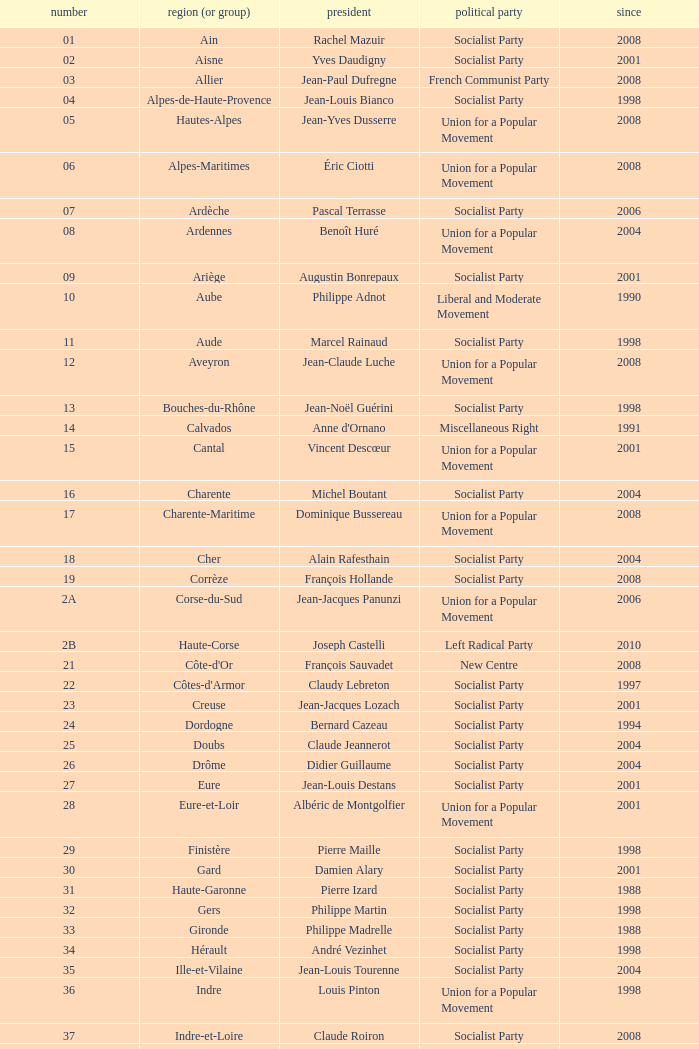Which department has Guy-Dominique Kennel as president since 2008? Bas-Rhin. Could you parse the entire table? {'header': ['number', 'region (or group)', 'president', 'political party', 'since'], 'rows': [['01', 'Ain', 'Rachel Mazuir', 'Socialist Party', '2008'], ['02', 'Aisne', 'Yves Daudigny', 'Socialist Party', '2001'], ['03', 'Allier', 'Jean-Paul Dufregne', 'French Communist Party', '2008'], ['04', 'Alpes-de-Haute-Provence', 'Jean-Louis Bianco', 'Socialist Party', '1998'], ['05', 'Hautes-Alpes', 'Jean-Yves Dusserre', 'Union for a Popular Movement', '2008'], ['06', 'Alpes-Maritimes', 'Éric Ciotti', 'Union for a Popular Movement', '2008'], ['07', 'Ardèche', 'Pascal Terrasse', 'Socialist Party', '2006'], ['08', 'Ardennes', 'Benoît Huré', 'Union for a Popular Movement', '2004'], ['09', 'Ariège', 'Augustin Bonrepaux', 'Socialist Party', '2001'], ['10', 'Aube', 'Philippe Adnot', 'Liberal and Moderate Movement', '1990'], ['11', 'Aude', 'Marcel Rainaud', 'Socialist Party', '1998'], ['12', 'Aveyron', 'Jean-Claude Luche', 'Union for a Popular Movement', '2008'], ['13', 'Bouches-du-Rhône', 'Jean-Noël Guérini', 'Socialist Party', '1998'], ['14', 'Calvados', "Anne d'Ornano", 'Miscellaneous Right', '1991'], ['15', 'Cantal', 'Vincent Descœur', 'Union for a Popular Movement', '2001'], ['16', 'Charente', 'Michel Boutant', 'Socialist Party', '2004'], ['17', 'Charente-Maritime', 'Dominique Bussereau', 'Union for a Popular Movement', '2008'], ['18', 'Cher', 'Alain Rafesthain', 'Socialist Party', '2004'], ['19', 'Corrèze', 'François Hollande', 'Socialist Party', '2008'], ['2A', 'Corse-du-Sud', 'Jean-Jacques Panunzi', 'Union for a Popular Movement', '2006'], ['2B', 'Haute-Corse', 'Joseph Castelli', 'Left Radical Party', '2010'], ['21', "Côte-d'Or", 'François Sauvadet', 'New Centre', '2008'], ['22', "Côtes-d'Armor", 'Claudy Lebreton', 'Socialist Party', '1997'], ['23', 'Creuse', 'Jean-Jacques Lozach', 'Socialist Party', '2001'], ['24', 'Dordogne', 'Bernard Cazeau', 'Socialist Party', '1994'], ['25', 'Doubs', 'Claude Jeannerot', 'Socialist Party', '2004'], ['26', 'Drôme', 'Didier Guillaume', 'Socialist Party', '2004'], ['27', 'Eure', 'Jean-Louis Destans', 'Socialist Party', '2001'], ['28', 'Eure-et-Loir', 'Albéric de Montgolfier', 'Union for a Popular Movement', '2001'], ['29', 'Finistère', 'Pierre Maille', 'Socialist Party', '1998'], ['30', 'Gard', 'Damien Alary', 'Socialist Party', '2001'], ['31', 'Haute-Garonne', 'Pierre Izard', 'Socialist Party', '1988'], ['32', 'Gers', 'Philippe Martin', 'Socialist Party', '1998'], ['33', 'Gironde', 'Philippe Madrelle', 'Socialist Party', '1988'], ['34', 'Hérault', 'André Vezinhet', 'Socialist Party', '1998'], ['35', 'Ille-et-Vilaine', 'Jean-Louis Tourenne', 'Socialist Party', '2004'], ['36', 'Indre', 'Louis Pinton', 'Union for a Popular Movement', '1998'], ['37', 'Indre-et-Loire', 'Claude Roiron', 'Socialist Party', '2008'], ['38', 'Isère', 'André Vallini', 'Socialist Party', '2001'], ['39', 'Jura', 'Jean Raquin', 'Miscellaneous Right', '2008'], ['40', 'Landes', 'Henri Emmanuelli', 'Socialist Party', '1982'], ['41', 'Loir-et-Cher', 'Maurice Leroy', 'New Centre', '2004'], ['42', 'Loire', 'Bernard Bonne', 'Union for a Popular Movement', '2008'], ['43', 'Haute-Loire', 'Gérard Roche', 'Union for a Popular Movement', '2004'], ['44', 'Loire-Atlantique', 'Patrick Mareschal', 'Socialist Party', '2004'], ['45', 'Loiret', 'Éric Doligé', 'Union for a Popular Movement', '1994'], ['46', 'Lot', 'Gérard Miquel', 'Socialist Party', '2004'], ['47', 'Lot-et-Garonne', 'Pierre Camani', 'Socialist Party', '2008'], ['48', 'Lozère', 'Jean-Paul Pourquier', 'Union for a Popular Movement', '2004'], ['49', 'Maine-et-Loire', 'Christophe Béchu', 'Union for a Popular Movement', '2004'], ['50', 'Manche', 'Jean-François Le Grand', 'Union for a Popular Movement', '1998'], ['51', 'Marne', 'René-Paul Savary', 'Union for a Popular Movement', '2003'], ['52', 'Haute-Marne', 'Bruno Sido', 'Union for a Popular Movement', '1998'], ['53', 'Mayenne', 'Jean Arthuis', 'Miscellaneous Centre', '1992'], ['54', 'Meurthe-et-Moselle', 'Michel Dinet', 'Socialist Party', '1998'], ['55', 'Meuse', 'Christian Namy', 'Miscellaneous Right', '2004'], ['56', 'Morbihan', 'Joseph-François Kerguéris', 'Democratic Movement', '2004'], ['57', 'Moselle', 'Philippe Leroy', 'Union for a Popular Movement', '1992'], ['58', 'Nièvre', 'Marcel Charmant', 'Socialist Party', '2001'], ['59', 'Nord', 'Patrick Kanner', 'Socialist Party', '1998'], ['60', 'Oise', 'Yves Rome', 'Socialist Party', '2004'], ['61', 'Orne', 'Alain Lambert', 'Union for a Popular Movement', '2007'], ['62', 'Pas-de-Calais', 'Dominique Dupilet', 'Socialist Party', '2004'], ['63', 'Puy-de-Dôme', 'Jean-Yves Gouttebel', 'Socialist Party', '2004'], ['64', 'Pyrénées-Atlantiques', 'Jean Castaings', 'Union for a Popular Movement', '2008'], ['65', 'Hautes-Pyrénées', 'Josette Durrieu', 'Socialist Party', '2008'], ['66', 'Pyrénées-Orientales', 'Christian Bourquin', 'Socialist Party', '1998'], ['67', 'Bas-Rhin', 'Guy-Dominique Kennel', 'Union for a Popular Movement', '2008'], ['68', 'Haut-Rhin', 'Charles Buttner', 'Union for a Popular Movement', '2004'], ['69', 'Rhône', 'Michel Mercier', 'Miscellaneous Centre', '1990'], ['70', 'Haute-Saône', 'Yves Krattinger', 'Socialist Party', '2002'], ['71', 'Saône-et-Loire', 'Arnaud Montebourg', 'Socialist Party', '2008'], ['72', 'Sarthe', 'Roland du Luart', 'Union for a Popular Movement', '1998'], ['73', 'Savoie', 'Hervé Gaymard', 'Union for a Popular Movement', '2008'], ['74', 'Haute-Savoie', 'Christian Monteil', 'Miscellaneous Right', '2008'], ['75', 'Paris', 'Bertrand Delanoë', 'Socialist Party', '2001'], ['76', 'Seine-Maritime', 'Didier Marie', 'Socialist Party', '2004'], ['77', 'Seine-et-Marne', 'Vincent Eblé', 'Socialist Party', '2004'], ['78', 'Yvelines', 'Pierre Bédier', 'Union for a Popular Movement', '2005'], ['79', 'Deux-Sèvres', 'Éric Gautier', 'Socialist Party', '2008'], ['80', 'Somme', 'Christian Manable', 'Socialist Party', '2008'], ['81', 'Tarn', 'Thierry Carcenac', 'Socialist Party', '1991'], ['82', 'Tarn-et-Garonne', 'Jean-Michel Baylet', 'Left Radical Party', '1986'], ['83', 'Var', 'Horace Lanfranchi', 'Union for a Popular Movement', '2002'], ['84', 'Vaucluse', 'Claude Haut', 'Socialist Party', '2001'], ['85', 'Vendée', 'Philippe de Villiers', 'Movement for France', '1988'], ['86', 'Vienne', 'Claude Bertaud', 'Union for a Popular Movement', '2008'], ['87', 'Haute-Vienne', 'Marie-Françoise Pérol-Dumont', 'Socialist Party', '2004'], ['88', 'Vosges', 'Christian Poncelet', 'Union for a Popular Movement', '1976'], ['89', 'Yonne', 'Jean-Marie Rolland', 'Union for a Popular Movement', '2008'], ['90', 'Territoire de Belfort', 'Yves Ackermann', 'Socialist Party', '2004'], ['91', 'Essonne', 'Michel Berson', 'Socialist Party', '1998'], ['92', 'Hauts-de-Seine', 'Patrick Devedjian', 'Union for a Popular Movement', '2007'], ['93', 'Seine-Saint-Denis', 'Claude Bartolone', 'Socialist Party', '2008'], ['94', 'Val-de-Marne', 'Christian Favier', 'French Communist Party', '2001'], ['95', 'Val-d’Oise', 'Arnaud Bazin', 'Union for a Popular Movement', '2011'], ['971', 'Guadeloupe', 'Jacques Gillot', 'United Guadeloupe, Socialism and Realities', '2001'], ['972', 'Martinique', 'Claude Lise', 'Martinican Democratic Rally', '1992'], ['973', 'Guyane', 'Alain Tien-Liong', 'Miscellaneous Left', '2008'], ['974', 'Réunion', 'Nassimah Dindar', 'Union for a Popular Movement', '2004'], ['975', 'Saint-Pierre-et-Miquelon (overseas collect.)', 'Stéphane Artano', 'Archipelago Tomorrow', '2006'], ['976', 'Mayotte (overseas collect.)', 'Ahmed Attoumani Douchina', 'Union for a Popular Movement', '2008']]} 